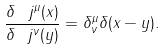<formula> <loc_0><loc_0><loc_500><loc_500>\frac { \delta \ j ^ { \mu } ( x ) } { \delta \ j ^ { \nu } ( y ) } = \delta _ { \nu } ^ { \mu } \delta ( x - y ) .</formula> 